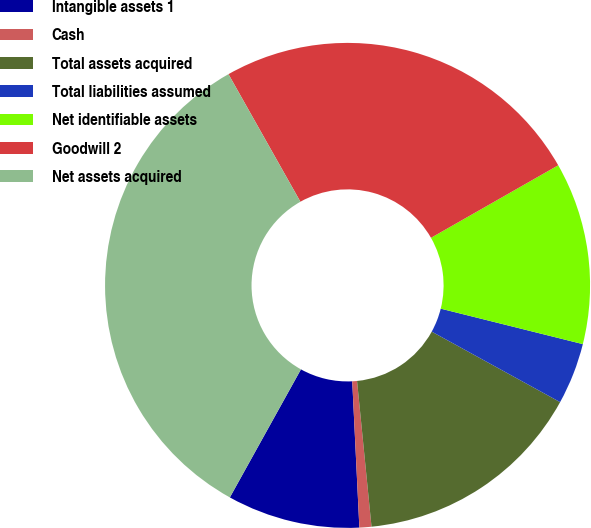<chart> <loc_0><loc_0><loc_500><loc_500><pie_chart><fcel>Intangible assets 1<fcel>Cash<fcel>Total assets acquired<fcel>Total liabilities assumed<fcel>Net identifiable assets<fcel>Goodwill 2<fcel>Net assets acquired<nl><fcel>8.84%<fcel>0.8%<fcel>15.43%<fcel>4.1%<fcel>12.14%<fcel>24.92%<fcel>33.76%<nl></chart> 